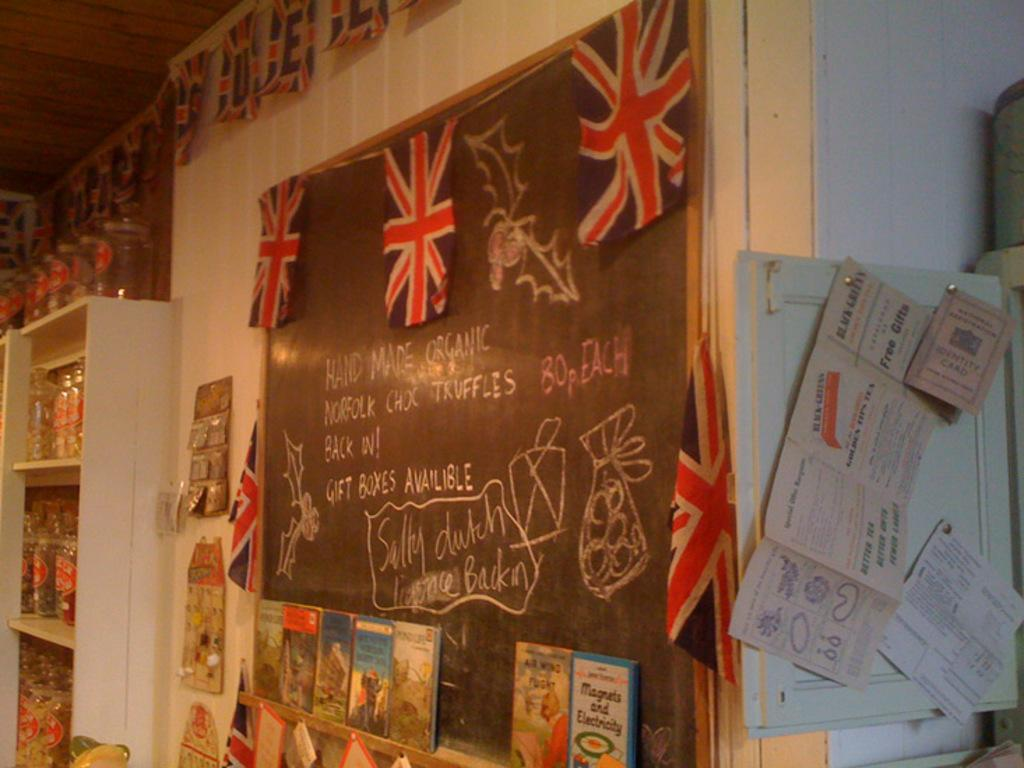<image>
Relay a brief, clear account of the picture shown. British flags hang on a chalkboard that describes some of the products available in the store. 